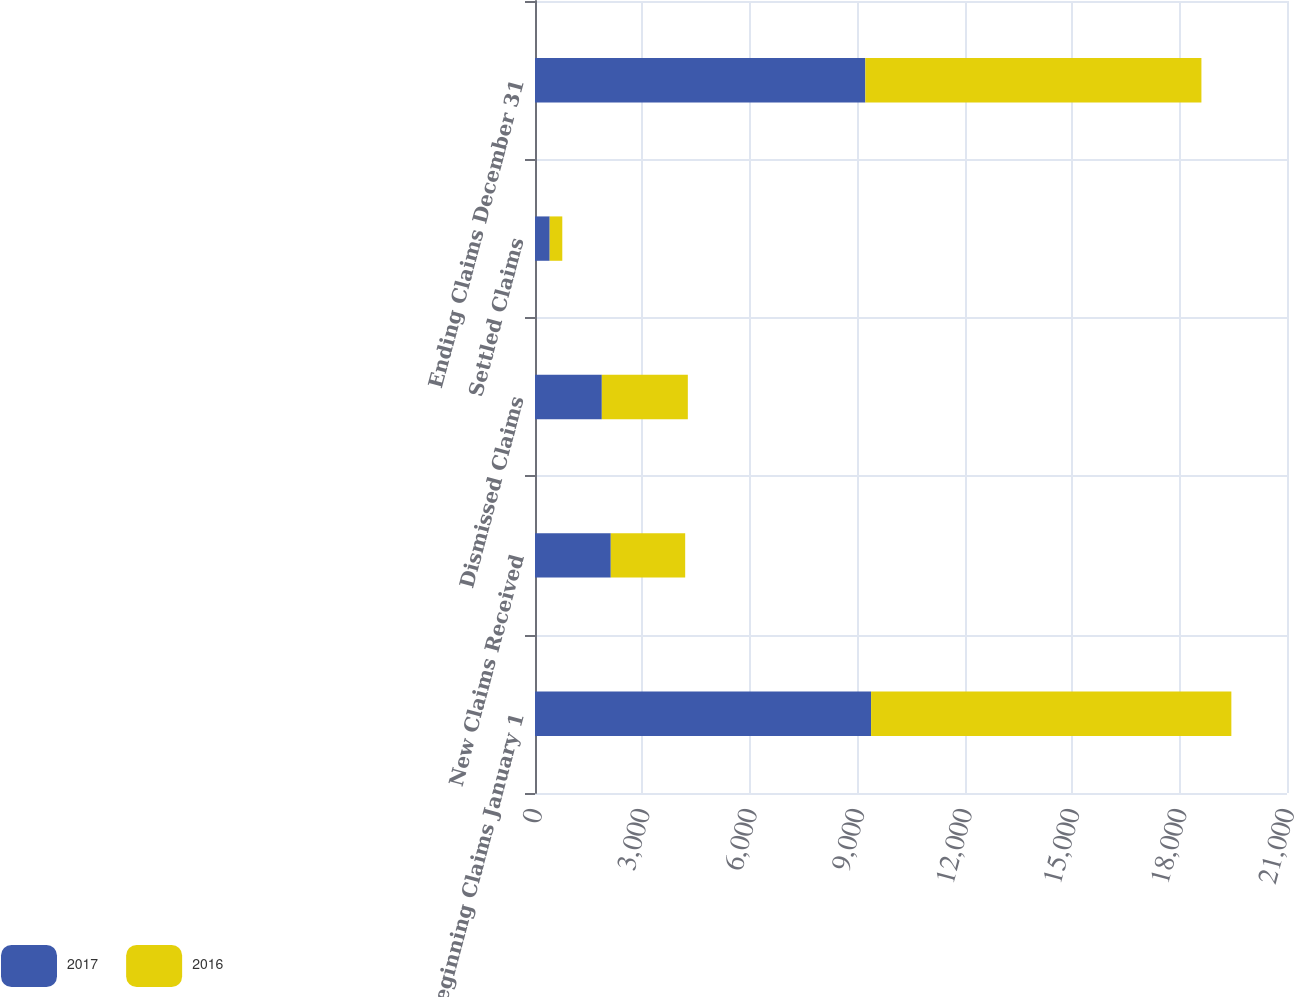<chart> <loc_0><loc_0><loc_500><loc_500><stacked_bar_chart><ecel><fcel>Beginning Claims January 1<fcel>New Claims Received<fcel>Dismissed Claims<fcel>Settled Claims<fcel>Ending Claims December 31<nl><fcel>2017<fcel>9385<fcel>2116<fcel>1866<fcel>410<fcel>9225<nl><fcel>2016<fcel>10061<fcel>2078<fcel>2402<fcel>352<fcel>9385<nl></chart> 